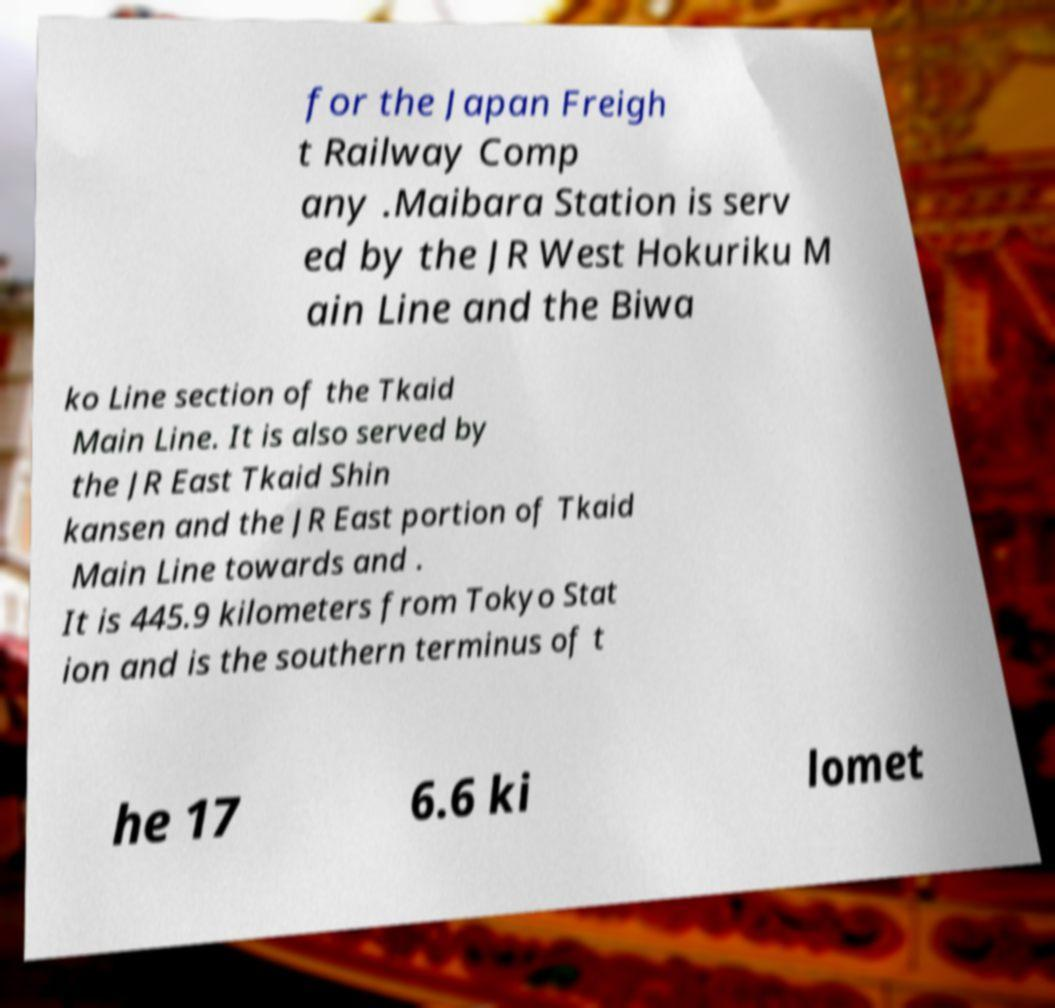I need the written content from this picture converted into text. Can you do that? for the Japan Freigh t Railway Comp any .Maibara Station is serv ed by the JR West Hokuriku M ain Line and the Biwa ko Line section of the Tkaid Main Line. It is also served by the JR East Tkaid Shin kansen and the JR East portion of Tkaid Main Line towards and . It is 445.9 kilometers from Tokyo Stat ion and is the southern terminus of t he 17 6.6 ki lomet 